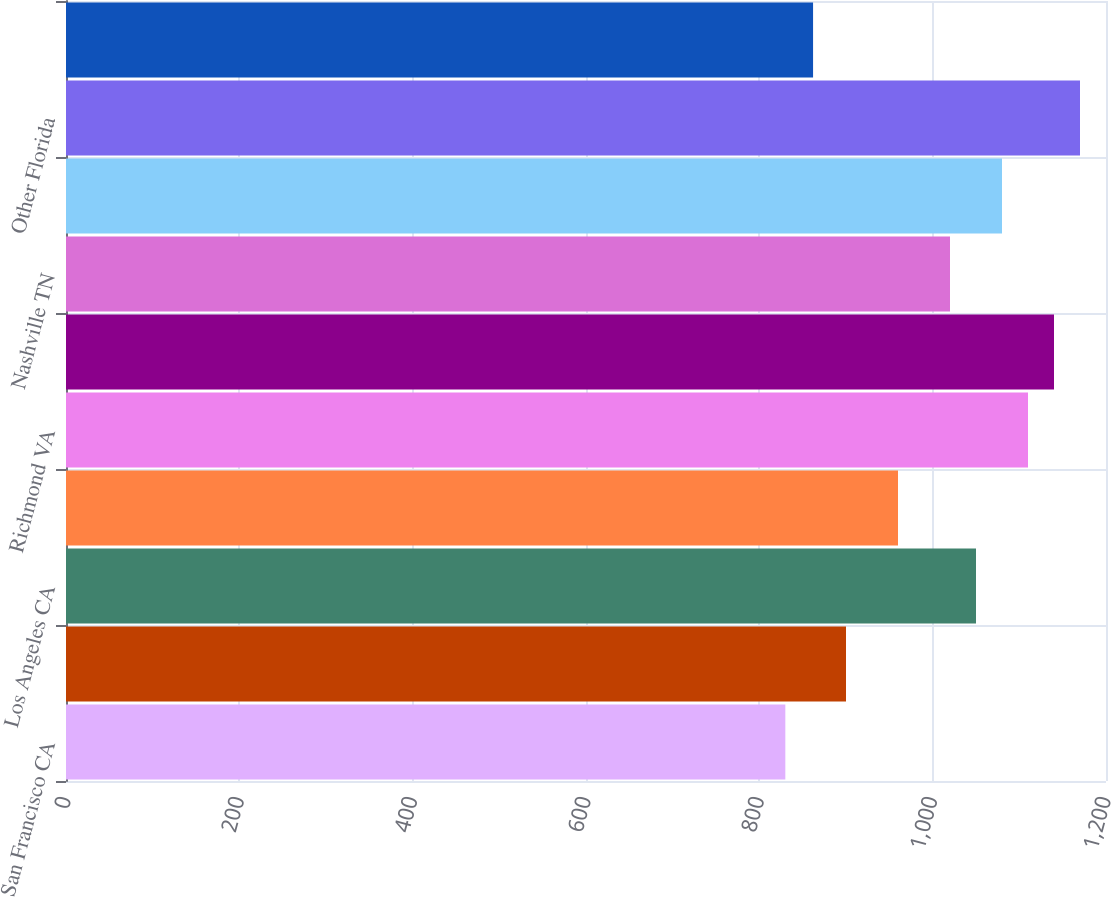Convert chart. <chart><loc_0><loc_0><loc_500><loc_500><bar_chart><fcel>San Francisco CA<fcel>Seattle WA<fcel>Los Angeles CA<fcel>Metropolitan DC<fcel>Richmond VA<fcel>Boston MA<fcel>Nashville TN<fcel>Tampa FL<fcel>Other Florida<fcel>Dallas TX<nl><fcel>830<fcel>900<fcel>1050<fcel>960<fcel>1110<fcel>1140<fcel>1020<fcel>1080<fcel>1170<fcel>862<nl></chart> 